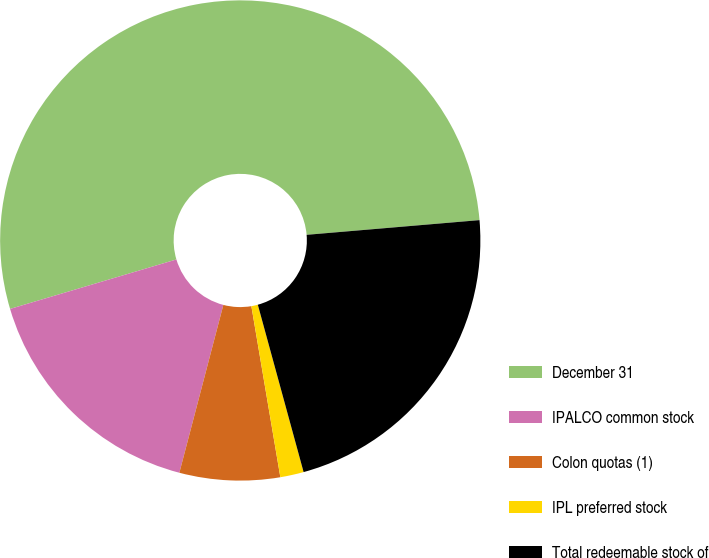Convert chart to OTSL. <chart><loc_0><loc_0><loc_500><loc_500><pie_chart><fcel>December 31<fcel>IPALCO common stock<fcel>Colon quotas (1)<fcel>IPL preferred stock<fcel>Total redeemable stock of<nl><fcel>53.25%<fcel>16.32%<fcel>6.75%<fcel>1.58%<fcel>22.1%<nl></chart> 